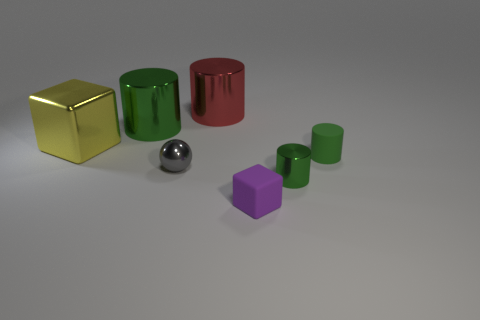There is a large cube that is the same material as the sphere; what is its color?
Offer a very short reply. Yellow. How many tiny things are the same color as the large metal block?
Offer a very short reply. 0. What number of objects are large brown matte balls or big metallic cylinders?
Keep it short and to the point. 2. There is another metallic thing that is the same size as the gray thing; what is its shape?
Your answer should be compact. Cylinder. What number of cylinders are both to the left of the gray shiny sphere and to the right of the small purple rubber thing?
Make the answer very short. 0. What is the material of the thing behind the large green object?
Your answer should be very brief. Metal. What size is the yellow object that is the same material as the ball?
Make the answer very short. Large. There is a green metallic cylinder to the left of the red metal cylinder; does it have the same size as the cylinder that is on the right side of the small green metal cylinder?
Your response must be concise. No. There is a cube that is the same size as the gray ball; what material is it?
Your answer should be compact. Rubber. There is a object that is both on the right side of the gray object and behind the green rubber cylinder; what is its material?
Your answer should be very brief. Metal. 